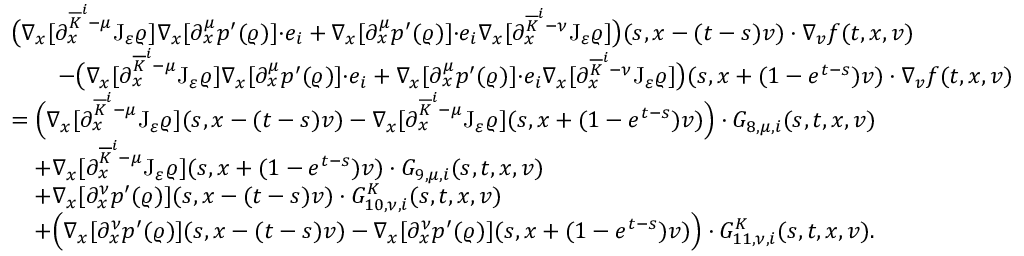<formula> <loc_0><loc_0><loc_500><loc_500>\begin{array} { r l } & { \left ( \nabla _ { x } [ \partial _ { x } ^ { \overline { K } ^ { i } - \mu } J _ { \varepsilon } \varrho ] \nabla _ { x } [ \partial _ { x } ^ { \mu } p ^ { \prime } ( \varrho ) ] { \cdot } e _ { i } + \nabla _ { x } [ \partial _ { x } ^ { \mu } p ^ { \prime } ( \varrho ) ] { \cdot } e _ { i } \nabla _ { x } [ \partial _ { x } ^ { \overline { K } ^ { i } - \nu } J _ { \varepsilon } \varrho ] \right ) ( s , x - ( t - s ) v ) \cdot \nabla _ { v } f ( t , x , v ) } \\ & { \quad - \left ( \nabla _ { x } [ \partial _ { x } ^ { \overline { K } ^ { i } - \mu } J _ { \varepsilon } \varrho ] \nabla _ { x } [ \partial _ { x } ^ { \mu } p ^ { \prime } ( \varrho ) ] { \cdot } e _ { i } + \nabla _ { x } [ \partial _ { x } ^ { \mu } p ^ { \prime } ( \varrho ) ] { \cdot } e _ { i } \nabla _ { x } [ \partial _ { x } ^ { \overline { K } ^ { i } - \nu } J _ { \varepsilon } \varrho ] \right ) ( s , x + ( 1 - e ^ { t - s } ) v ) \cdot \nabla _ { v } f ( t , x , v ) } \\ & { = \left ( \nabla _ { x } [ \partial _ { x } ^ { \overline { K } ^ { i } - \mu } J _ { \varepsilon } \varrho ] ( s , x - ( t - s ) v ) - \nabla _ { x } [ \partial _ { x } ^ { \overline { K } ^ { i } - \mu } J _ { \varepsilon } \varrho ] ( s , x + ( 1 - e ^ { t - s } ) v ) \right ) \cdot G _ { 8 , \mu , i } ( s , t , x , v ) } \\ & { \quad + \nabla _ { x } [ \partial _ { x } ^ { \overline { K } ^ { i } - \mu } J _ { \varepsilon } \varrho ] ( s , x + ( 1 - e ^ { t - s } ) v ) \cdot G _ { 9 , \mu , i } ( s , t , x , v ) } \\ & { \quad + \nabla _ { x } [ \partial _ { x } ^ { \nu } p ^ { \prime } ( \varrho ) ] ( s , x - ( t - s ) v ) \cdot G _ { 1 0 , \nu , i } ^ { K } ( s , t , x , v ) } \\ & { \quad + \left ( \nabla _ { x } [ \partial _ { x } ^ { \nu } p ^ { \prime } ( \varrho ) ] ( s , x - ( t - s ) v ) - \nabla _ { x } [ \partial _ { x } ^ { \nu } p ^ { \prime } ( \varrho ) ] ( s , x + ( 1 - e ^ { t - s } ) v ) \right ) \cdot G _ { 1 1 , \nu , i } ^ { K } ( s , t , x , v ) . } \end{array}</formula> 